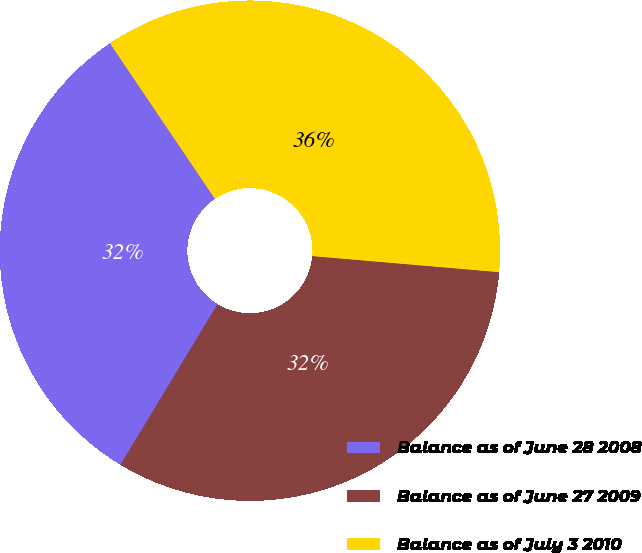<chart> <loc_0><loc_0><loc_500><loc_500><pie_chart><fcel>Balance as of June 28 2008<fcel>Balance as of June 27 2009<fcel>Balance as of July 3 2010<nl><fcel>31.9%<fcel>32.29%<fcel>35.81%<nl></chart> 